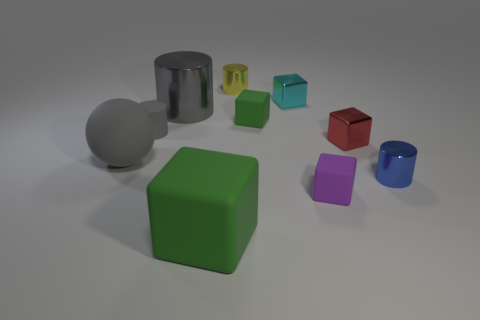Subtract all brown blocks. How many gray cylinders are left? 2 Subtract all tiny rubber cubes. How many cubes are left? 3 Subtract 3 cubes. How many cubes are left? 2 Subtract all red cubes. How many cubes are left? 4 Subtract all red cylinders. Subtract all purple cubes. How many cylinders are left? 4 Subtract all cylinders. How many objects are left? 6 Add 8 blue metallic things. How many blue metallic things exist? 9 Subtract 0 purple balls. How many objects are left? 10 Subtract all big blocks. Subtract all tiny red metal objects. How many objects are left? 8 Add 3 matte cylinders. How many matte cylinders are left? 4 